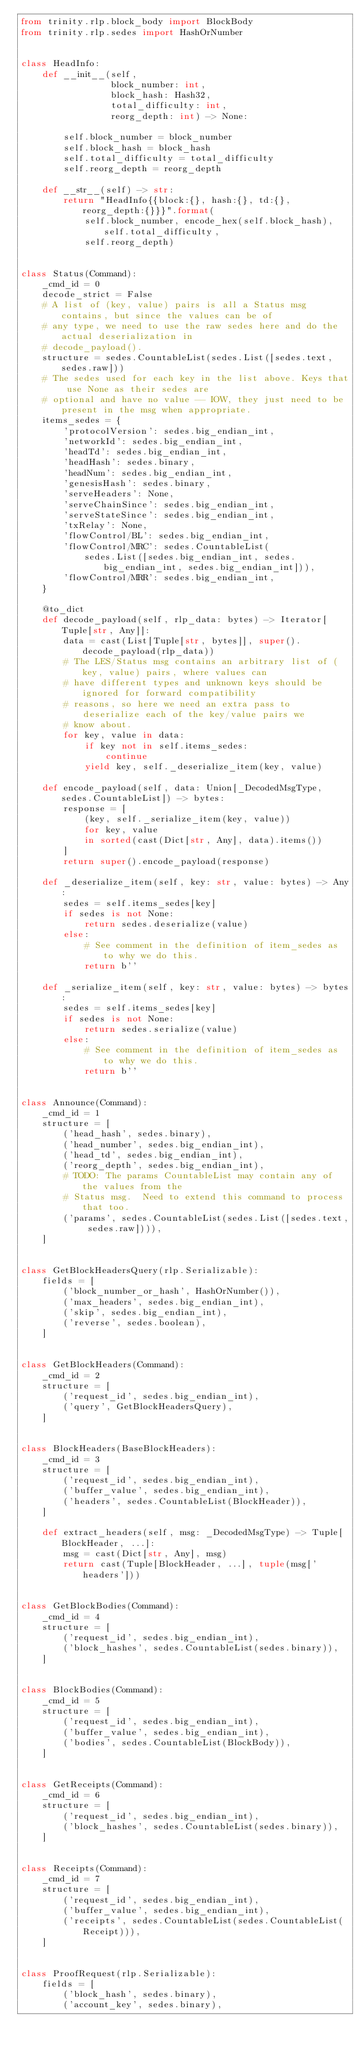Convert code to text. <code><loc_0><loc_0><loc_500><loc_500><_Python_>from trinity.rlp.block_body import BlockBody
from trinity.rlp.sedes import HashOrNumber


class HeadInfo:
    def __init__(self,
                 block_number: int,
                 block_hash: Hash32,
                 total_difficulty: int,
                 reorg_depth: int) -> None:

        self.block_number = block_number
        self.block_hash = block_hash
        self.total_difficulty = total_difficulty
        self.reorg_depth = reorg_depth

    def __str__(self) -> str:
        return "HeadInfo{{block:{}, hash:{}, td:{}, reorg_depth:{}}}".format(
            self.block_number, encode_hex(self.block_hash), self.total_difficulty,
            self.reorg_depth)


class Status(Command):
    _cmd_id = 0
    decode_strict = False
    # A list of (key, value) pairs is all a Status msg contains, but since the values can be of
    # any type, we need to use the raw sedes here and do the actual deserialization in
    # decode_payload().
    structure = sedes.CountableList(sedes.List([sedes.text, sedes.raw]))
    # The sedes used for each key in the list above. Keys that use None as their sedes are
    # optional and have no value -- IOW, they just need to be present in the msg when appropriate.
    items_sedes = {
        'protocolVersion': sedes.big_endian_int,
        'networkId': sedes.big_endian_int,
        'headTd': sedes.big_endian_int,
        'headHash': sedes.binary,
        'headNum': sedes.big_endian_int,
        'genesisHash': sedes.binary,
        'serveHeaders': None,
        'serveChainSince': sedes.big_endian_int,
        'serveStateSince': sedes.big_endian_int,
        'txRelay': None,
        'flowControl/BL': sedes.big_endian_int,
        'flowControl/MRC': sedes.CountableList(
            sedes.List([sedes.big_endian_int, sedes.big_endian_int, sedes.big_endian_int])),
        'flowControl/MRR': sedes.big_endian_int,
    }

    @to_dict
    def decode_payload(self, rlp_data: bytes) -> Iterator[Tuple[str, Any]]:
        data = cast(List[Tuple[str, bytes]], super().decode_payload(rlp_data))
        # The LES/Status msg contains an arbitrary list of (key, value) pairs, where values can
        # have different types and unknown keys should be ignored for forward compatibility
        # reasons, so here we need an extra pass to deserialize each of the key/value pairs we
        # know about.
        for key, value in data:
            if key not in self.items_sedes:
                continue
            yield key, self._deserialize_item(key, value)

    def encode_payload(self, data: Union[_DecodedMsgType, sedes.CountableList]) -> bytes:
        response = [
            (key, self._serialize_item(key, value))
            for key, value
            in sorted(cast(Dict[str, Any], data).items())
        ]
        return super().encode_payload(response)

    def _deserialize_item(self, key: str, value: bytes) -> Any:
        sedes = self.items_sedes[key]
        if sedes is not None:
            return sedes.deserialize(value)
        else:
            # See comment in the definition of item_sedes as to why we do this.
            return b''

    def _serialize_item(self, key: str, value: bytes) -> bytes:
        sedes = self.items_sedes[key]
        if sedes is not None:
            return sedes.serialize(value)
        else:
            # See comment in the definition of item_sedes as to why we do this.
            return b''


class Announce(Command):
    _cmd_id = 1
    structure = [
        ('head_hash', sedes.binary),
        ('head_number', sedes.big_endian_int),
        ('head_td', sedes.big_endian_int),
        ('reorg_depth', sedes.big_endian_int),
        # TODO: The params CountableList may contain any of the values from the
        # Status msg.  Need to extend this command to process that too.
        ('params', sedes.CountableList(sedes.List([sedes.text, sedes.raw]))),
    ]


class GetBlockHeadersQuery(rlp.Serializable):
    fields = [
        ('block_number_or_hash', HashOrNumber()),
        ('max_headers', sedes.big_endian_int),
        ('skip', sedes.big_endian_int),
        ('reverse', sedes.boolean),
    ]


class GetBlockHeaders(Command):
    _cmd_id = 2
    structure = [
        ('request_id', sedes.big_endian_int),
        ('query', GetBlockHeadersQuery),
    ]


class BlockHeaders(BaseBlockHeaders):
    _cmd_id = 3
    structure = [
        ('request_id', sedes.big_endian_int),
        ('buffer_value', sedes.big_endian_int),
        ('headers', sedes.CountableList(BlockHeader)),
    ]

    def extract_headers(self, msg: _DecodedMsgType) -> Tuple[BlockHeader, ...]:
        msg = cast(Dict[str, Any], msg)
        return cast(Tuple[BlockHeader, ...], tuple(msg['headers']))


class GetBlockBodies(Command):
    _cmd_id = 4
    structure = [
        ('request_id', sedes.big_endian_int),
        ('block_hashes', sedes.CountableList(sedes.binary)),
    ]


class BlockBodies(Command):
    _cmd_id = 5
    structure = [
        ('request_id', sedes.big_endian_int),
        ('buffer_value', sedes.big_endian_int),
        ('bodies', sedes.CountableList(BlockBody)),
    ]


class GetReceipts(Command):
    _cmd_id = 6
    structure = [
        ('request_id', sedes.big_endian_int),
        ('block_hashes', sedes.CountableList(sedes.binary)),
    ]


class Receipts(Command):
    _cmd_id = 7
    structure = [
        ('request_id', sedes.big_endian_int),
        ('buffer_value', sedes.big_endian_int),
        ('receipts', sedes.CountableList(sedes.CountableList(Receipt))),
    ]


class ProofRequest(rlp.Serializable):
    fields = [
        ('block_hash', sedes.binary),
        ('account_key', sedes.binary),</code> 